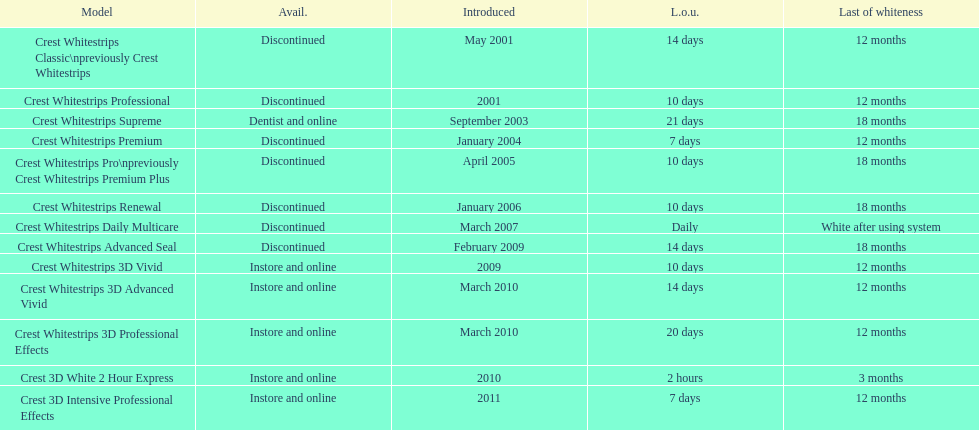Is each white strip discontinued? No. Give me the full table as a dictionary. {'header': ['Model', 'Avail.', 'Introduced', 'L.o.u.', 'Last of whiteness'], 'rows': [['Crest Whitestrips Classic\\npreviously Crest Whitestrips', 'Discontinued', 'May 2001', '14 days', '12 months'], ['Crest Whitestrips Professional', 'Discontinued', '2001', '10 days', '12 months'], ['Crest Whitestrips Supreme', 'Dentist and online', 'September 2003', '21 days', '18 months'], ['Crest Whitestrips Premium', 'Discontinued', 'January 2004', '7 days', '12 months'], ['Crest Whitestrips Pro\\npreviously Crest Whitestrips Premium Plus', 'Discontinued', 'April 2005', '10 days', '18 months'], ['Crest Whitestrips Renewal', 'Discontinued', 'January 2006', '10 days', '18 months'], ['Crest Whitestrips Daily Multicare', 'Discontinued', 'March 2007', 'Daily', 'White after using system'], ['Crest Whitestrips Advanced Seal', 'Discontinued', 'February 2009', '14 days', '18 months'], ['Crest Whitestrips 3D Vivid', 'Instore and online', '2009', '10 days', '12 months'], ['Crest Whitestrips 3D Advanced Vivid', 'Instore and online', 'March 2010', '14 days', '12 months'], ['Crest Whitestrips 3D Professional Effects', 'Instore and online', 'March 2010', '20 days', '12 months'], ['Crest 3D White 2 Hour Express', 'Instore and online', '2010', '2 hours', '3 months'], ['Crest 3D Intensive Professional Effects', 'Instore and online', '2011', '7 days', '12 months']]} 